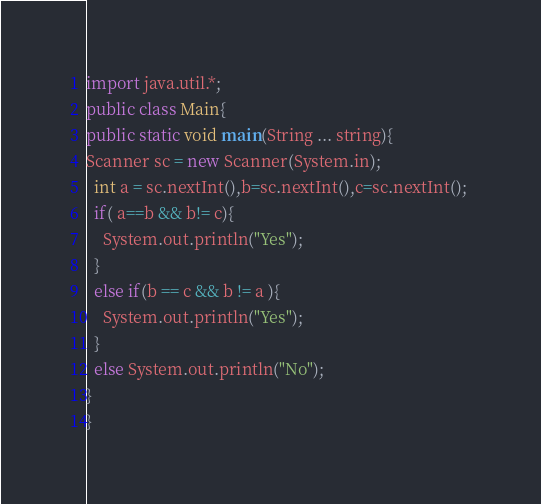<code> <loc_0><loc_0><loc_500><loc_500><_Java_>import java.util.*; 
public class Main{
public static void main(String ... string){
Scanner sc = new Scanner(System.in); 
  int a = sc.nextInt(),b=sc.nextInt(),c=sc.nextInt(); 
  if( a==b && b!= c){
    System.out.println("Yes"); 
  }
  else if(b == c && b != a ){
    System.out.println("Yes"); 
  }
  else System.out.println("No"); 
}
}</code> 